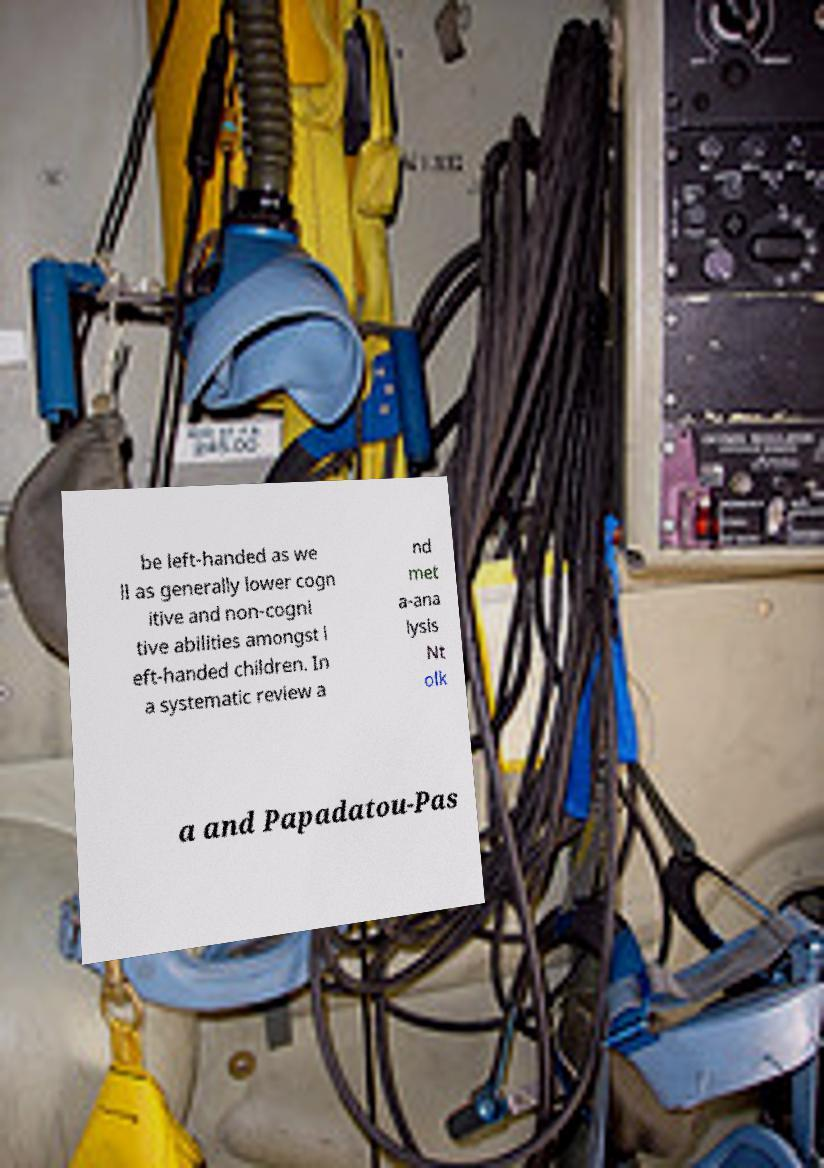I need the written content from this picture converted into text. Can you do that? be left-handed as we ll as generally lower cogn itive and non-cogni tive abilities amongst l eft-handed children. In a systematic review a nd met a-ana lysis Nt olk a and Papadatou-Pas 